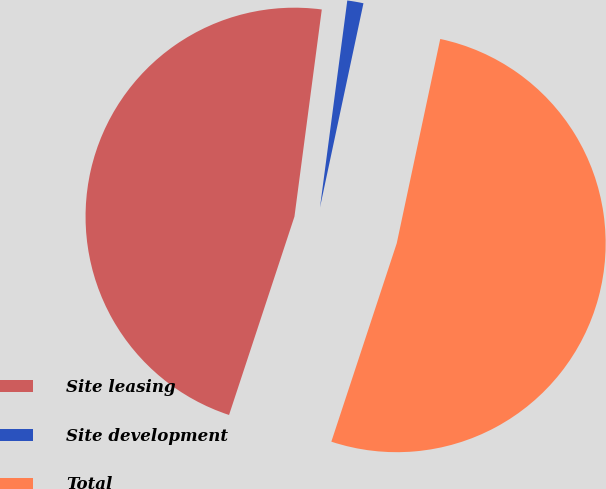Convert chart to OTSL. <chart><loc_0><loc_0><loc_500><loc_500><pie_chart><fcel>Site leasing<fcel>Site development<fcel>Total<nl><fcel>47.02%<fcel>1.25%<fcel>51.73%<nl></chart> 